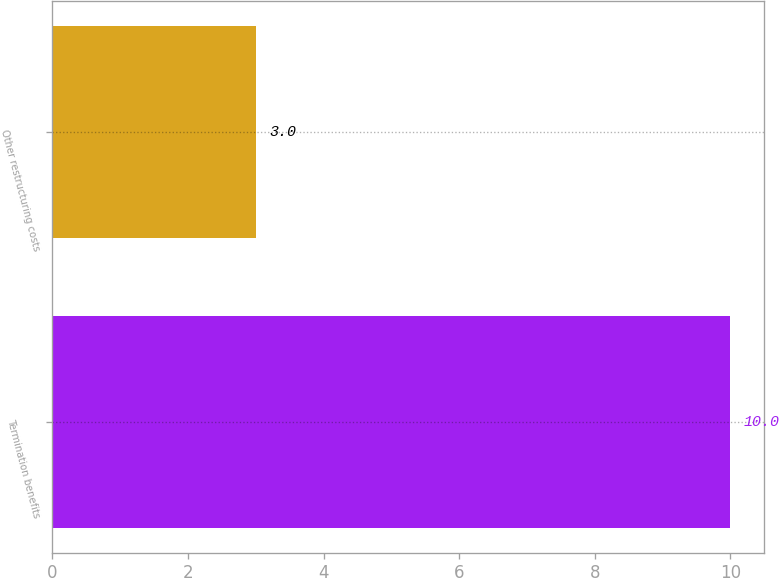Convert chart. <chart><loc_0><loc_0><loc_500><loc_500><bar_chart><fcel>Termination benefits<fcel>Other restructuring costs<nl><fcel>10<fcel>3<nl></chart> 